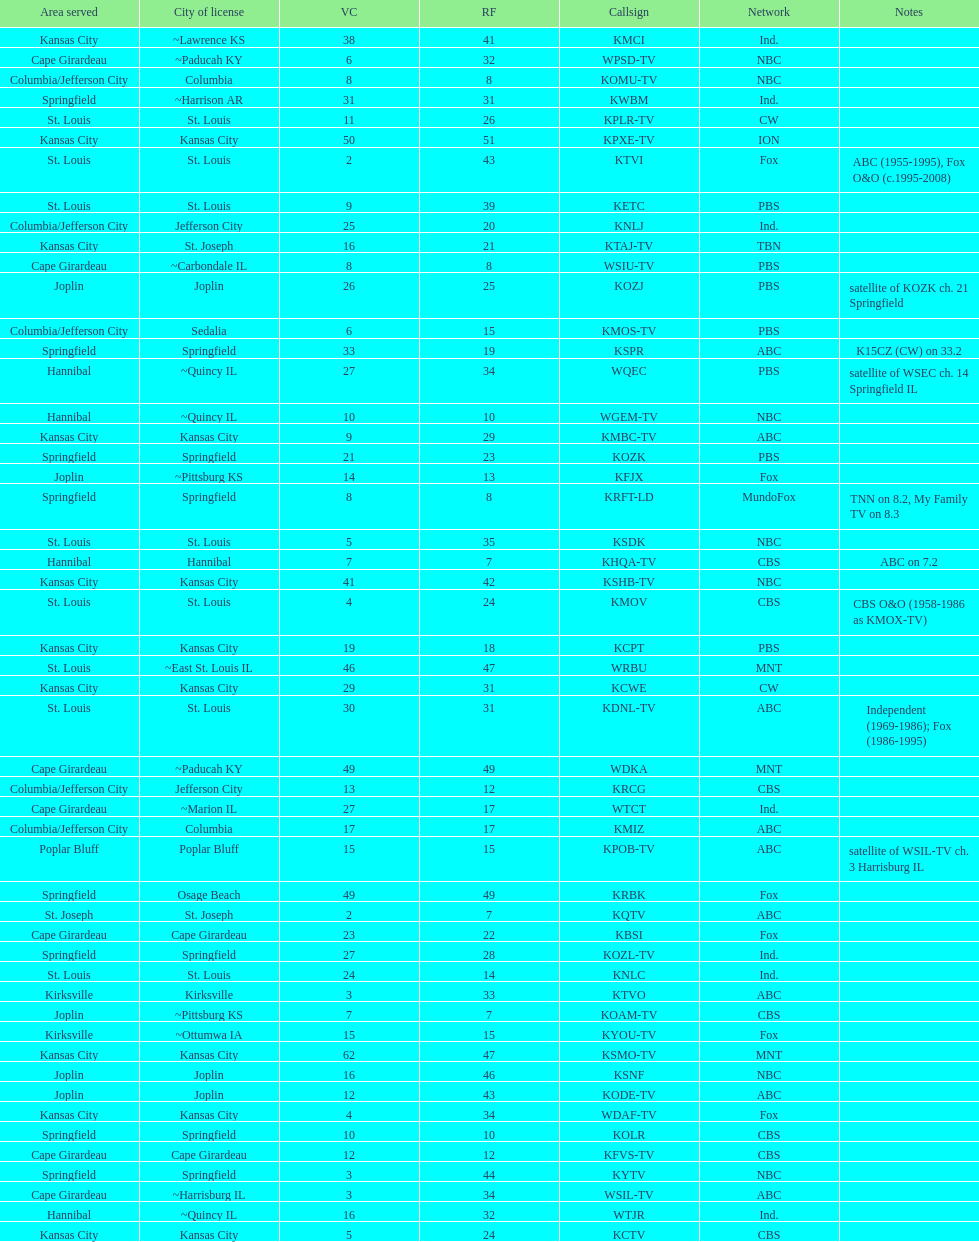Which station is licensed in the same city as koam-tv? KFJX. 